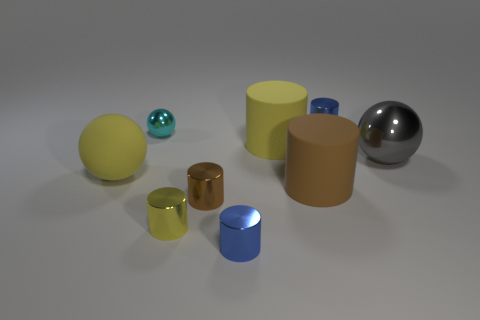Subtract all purple blocks. How many yellow cylinders are left? 2 Subtract all large spheres. How many spheres are left? 1 Subtract all brown cylinders. How many cylinders are left? 4 Add 1 big cyan blocks. How many objects exist? 10 Subtract 2 cylinders. How many cylinders are left? 4 Subtract all cylinders. How many objects are left? 3 Subtract all gray cylinders. Subtract all yellow spheres. How many cylinders are left? 6 Add 6 brown matte spheres. How many brown matte spheres exist? 6 Subtract 0 purple cubes. How many objects are left? 9 Subtract all large blue matte cylinders. Subtract all large yellow matte things. How many objects are left? 7 